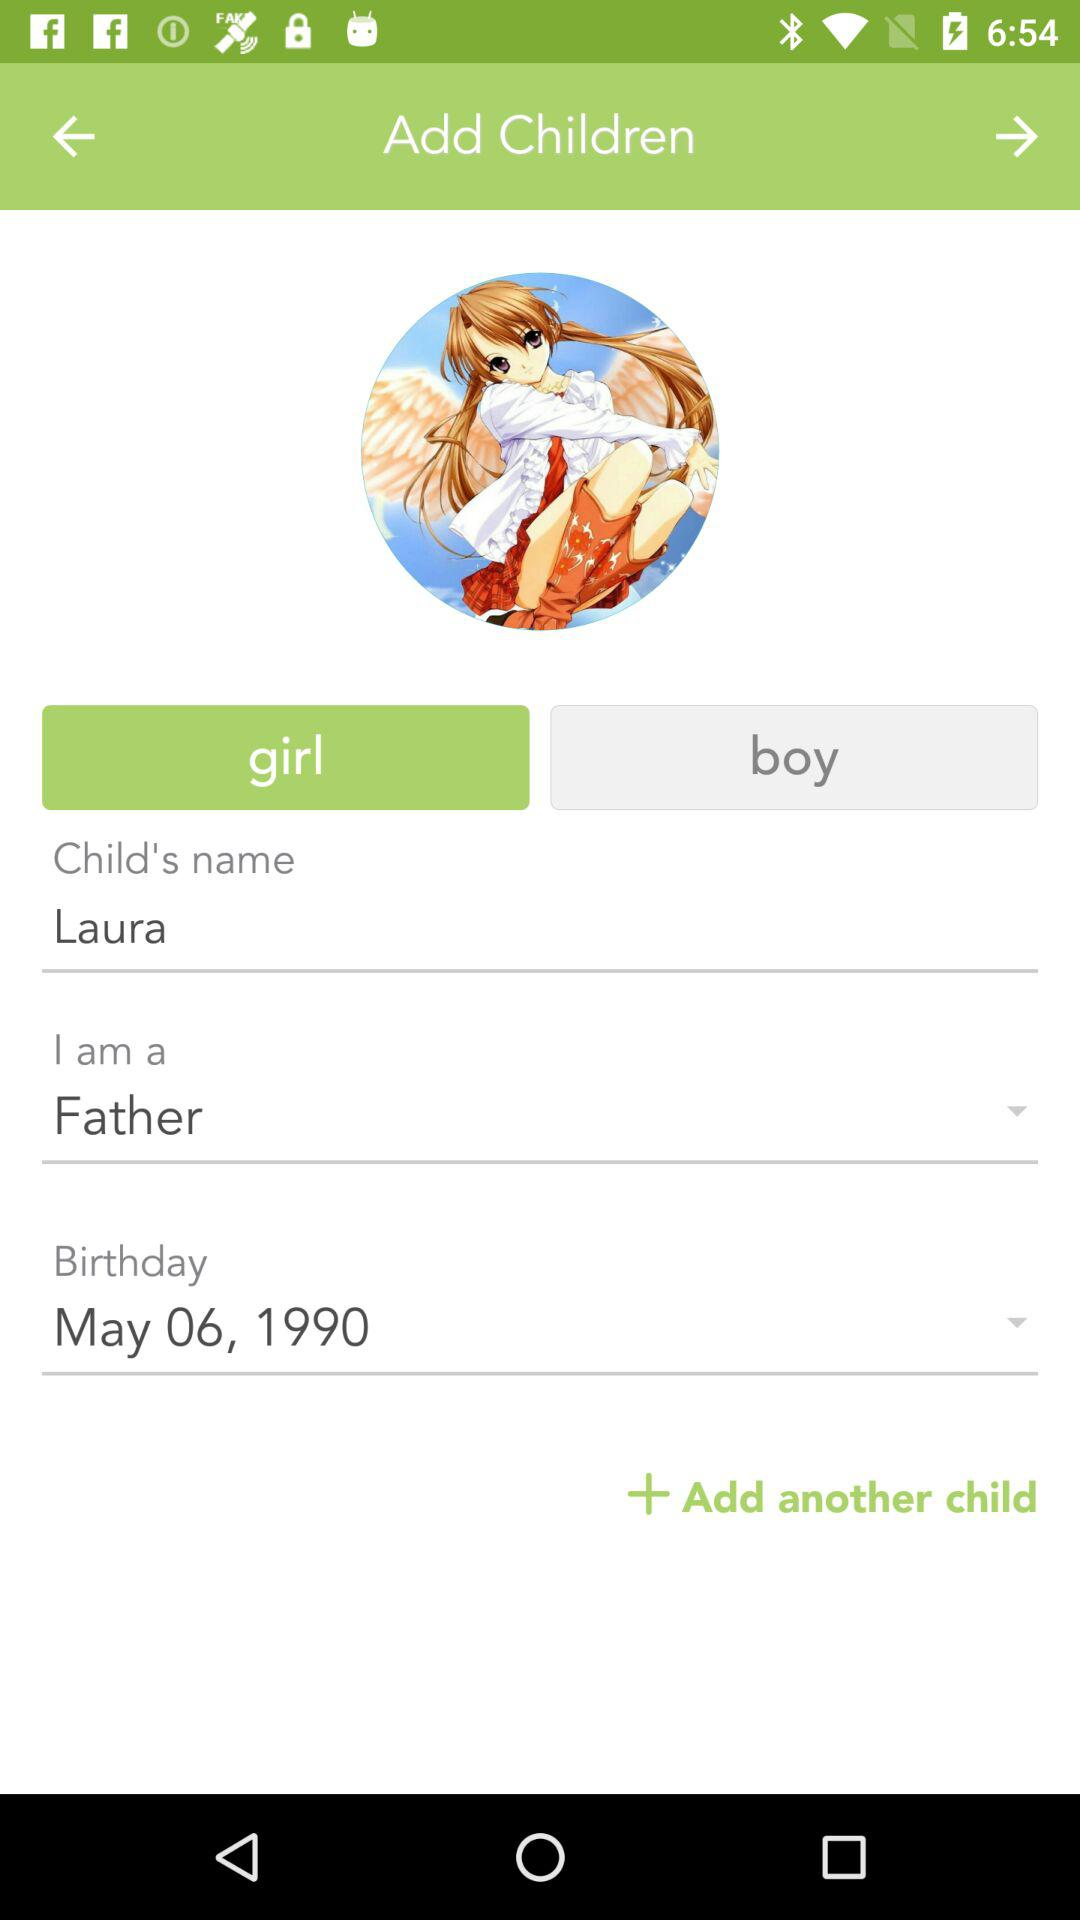How many fields are there to add a child?
Answer the question using a single word or phrase. 4 